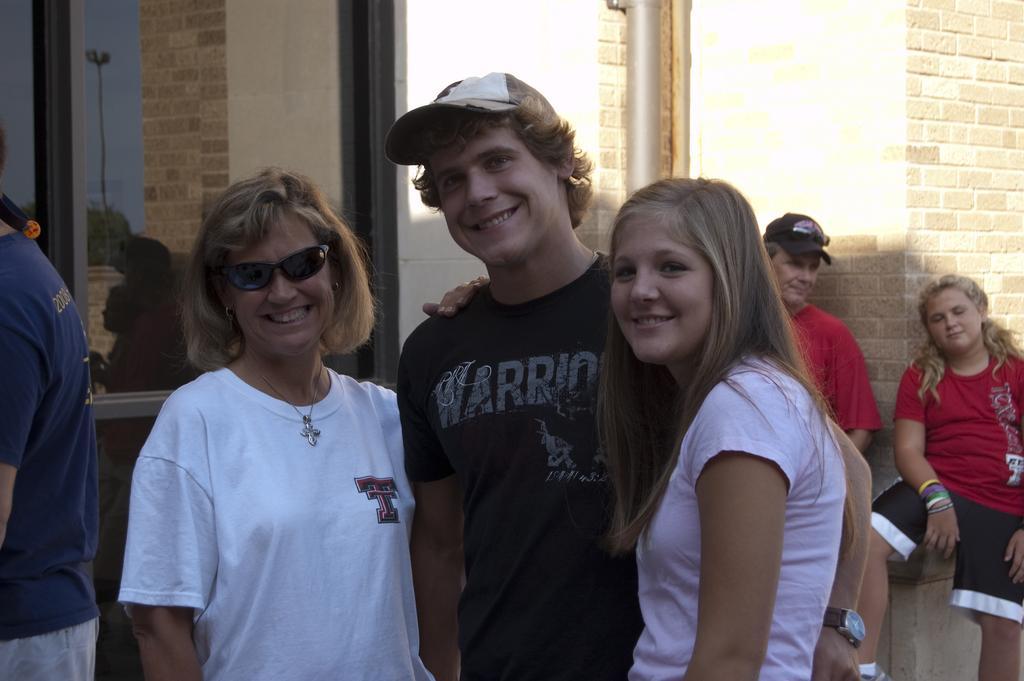Describe this image in one or two sentences. There are people standing and we can see wall and glass windows,through this glass window we can see trees and sky. 